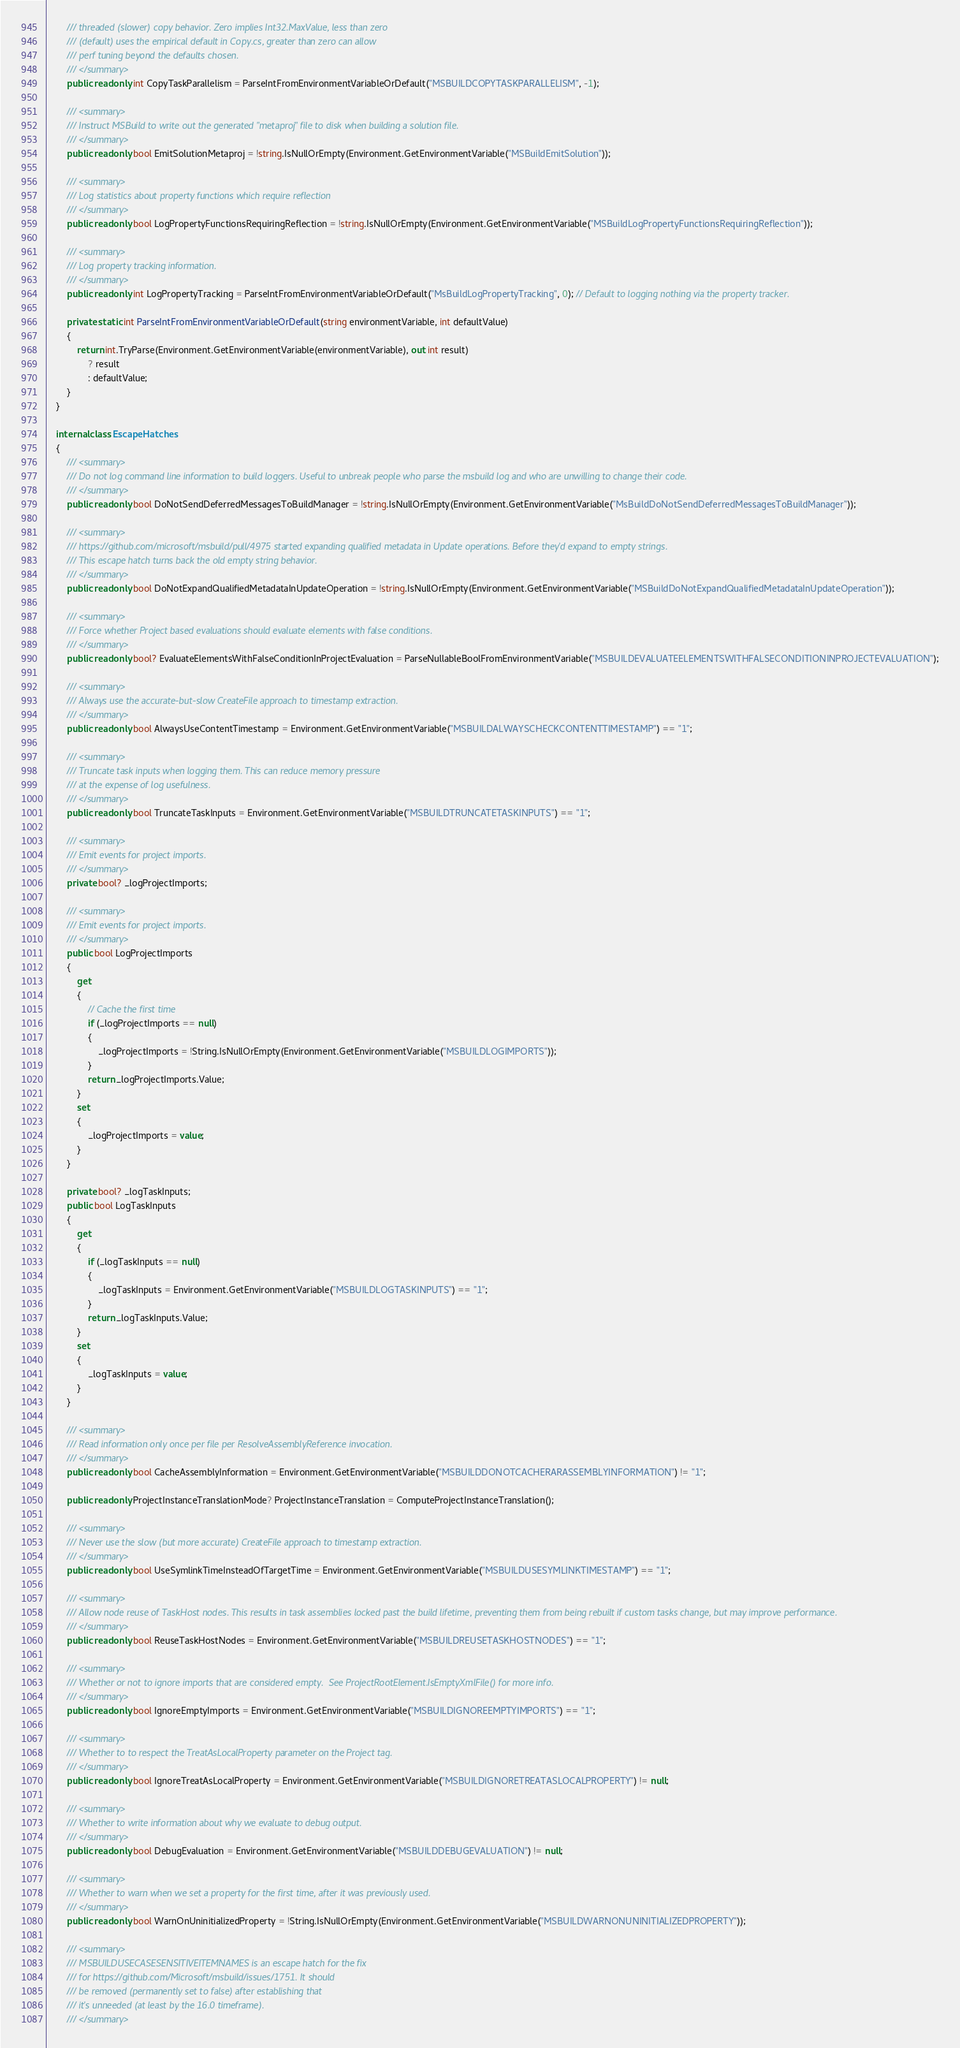Convert code to text. <code><loc_0><loc_0><loc_500><loc_500><_C#_>        /// threaded (slower) copy behavior. Zero implies Int32.MaxValue, less than zero
        /// (default) uses the empirical default in Copy.cs, greater than zero can allow
        /// perf tuning beyond the defaults chosen.
        /// </summary>
        public readonly int CopyTaskParallelism = ParseIntFromEnvironmentVariableOrDefault("MSBUILDCOPYTASKPARALLELISM", -1);

        /// <summary>
        /// Instruct MSBuild to write out the generated "metaproj" file to disk when building a solution file.
        /// </summary>
        public readonly bool EmitSolutionMetaproj = !string.IsNullOrEmpty(Environment.GetEnvironmentVariable("MSBuildEmitSolution"));

        /// <summary>
        /// Log statistics about property functions which require reflection
        /// </summary>
        public readonly bool LogPropertyFunctionsRequiringReflection = !string.IsNullOrEmpty(Environment.GetEnvironmentVariable("MSBuildLogPropertyFunctionsRequiringReflection"));

        /// <summary>
        /// Log property tracking information.
        /// </summary>
        public readonly int LogPropertyTracking = ParseIntFromEnvironmentVariableOrDefault("MsBuildLogPropertyTracking", 0); // Default to logging nothing via the property tracker.

        private static int ParseIntFromEnvironmentVariableOrDefault(string environmentVariable, int defaultValue)
        {
            return int.TryParse(Environment.GetEnvironmentVariable(environmentVariable), out int result)
                ? result
                : defaultValue;
        }
    }

    internal class EscapeHatches
    {
        /// <summary>
        /// Do not log command line information to build loggers. Useful to unbreak people who parse the msbuild log and who are unwilling to change their code.
        /// </summary>
        public readonly bool DoNotSendDeferredMessagesToBuildManager = !string.IsNullOrEmpty(Environment.GetEnvironmentVariable("MsBuildDoNotSendDeferredMessagesToBuildManager"));

        /// <summary>
        /// https://github.com/microsoft/msbuild/pull/4975 started expanding qualified metadata in Update operations. Before they'd expand to empty strings.
        /// This escape hatch turns back the old empty string behavior.
        /// </summary>
        public readonly bool DoNotExpandQualifiedMetadataInUpdateOperation = !string.IsNullOrEmpty(Environment.GetEnvironmentVariable("MSBuildDoNotExpandQualifiedMetadataInUpdateOperation"));

        /// <summary>
        /// Force whether Project based evaluations should evaluate elements with false conditions.
        /// </summary>
        public readonly bool? EvaluateElementsWithFalseConditionInProjectEvaluation = ParseNullableBoolFromEnvironmentVariable("MSBUILDEVALUATEELEMENTSWITHFALSECONDITIONINPROJECTEVALUATION");

        /// <summary>
        /// Always use the accurate-but-slow CreateFile approach to timestamp extraction.
        /// </summary>
        public readonly bool AlwaysUseContentTimestamp = Environment.GetEnvironmentVariable("MSBUILDALWAYSCHECKCONTENTTIMESTAMP") == "1";

        /// <summary>
        /// Truncate task inputs when logging them. This can reduce memory pressure
        /// at the expense of log usefulness.
        /// </summary>
        public readonly bool TruncateTaskInputs = Environment.GetEnvironmentVariable("MSBUILDTRUNCATETASKINPUTS") == "1";

        /// <summary>
        /// Emit events for project imports.
        /// </summary>
        private bool? _logProjectImports;

        /// <summary>
        /// Emit events for project imports.
        /// </summary>
        public bool LogProjectImports
        {
            get
            {
                // Cache the first time
                if (_logProjectImports == null)
                {
                    _logProjectImports = !String.IsNullOrEmpty(Environment.GetEnvironmentVariable("MSBUILDLOGIMPORTS"));
                }
                return _logProjectImports.Value;
            }
            set
            {
                _logProjectImports = value;
            }
        }

        private bool? _logTaskInputs;
        public bool LogTaskInputs
        {
            get
            {
                if (_logTaskInputs == null)
                {
                    _logTaskInputs = Environment.GetEnvironmentVariable("MSBUILDLOGTASKINPUTS") == "1";
                }
                return _logTaskInputs.Value;
            }
            set
            {
                _logTaskInputs = value;
            }
        }

        /// <summary>
        /// Read information only once per file per ResolveAssemblyReference invocation.
        /// </summary>
        public readonly bool CacheAssemblyInformation = Environment.GetEnvironmentVariable("MSBUILDDONOTCACHERARASSEMBLYINFORMATION") != "1";

        public readonly ProjectInstanceTranslationMode? ProjectInstanceTranslation = ComputeProjectInstanceTranslation();

        /// <summary>
        /// Never use the slow (but more accurate) CreateFile approach to timestamp extraction.
        /// </summary>
        public readonly bool UseSymlinkTimeInsteadOfTargetTime = Environment.GetEnvironmentVariable("MSBUILDUSESYMLINKTIMESTAMP") == "1";

        /// <summary>
        /// Allow node reuse of TaskHost nodes. This results in task assemblies locked past the build lifetime, preventing them from being rebuilt if custom tasks change, but may improve performance.
        /// </summary>
        public readonly bool ReuseTaskHostNodes = Environment.GetEnvironmentVariable("MSBUILDREUSETASKHOSTNODES") == "1";

        /// <summary>
        /// Whether or not to ignore imports that are considered empty.  See ProjectRootElement.IsEmptyXmlFile() for more info.
        /// </summary>
        public readonly bool IgnoreEmptyImports = Environment.GetEnvironmentVariable("MSBUILDIGNOREEMPTYIMPORTS") == "1";

        /// <summary>
        /// Whether to to respect the TreatAsLocalProperty parameter on the Project tag. 
        /// </summary>
        public readonly bool IgnoreTreatAsLocalProperty = Environment.GetEnvironmentVariable("MSBUILDIGNORETREATASLOCALPROPERTY") != null;

        /// <summary>
        /// Whether to write information about why we evaluate to debug output.
        /// </summary>
        public readonly bool DebugEvaluation = Environment.GetEnvironmentVariable("MSBUILDDEBUGEVALUATION") != null;

        /// <summary>
        /// Whether to warn when we set a property for the first time, after it was previously used.
        /// </summary>
        public readonly bool WarnOnUninitializedProperty = !String.IsNullOrEmpty(Environment.GetEnvironmentVariable("MSBUILDWARNONUNINITIALIZEDPROPERTY"));

        /// <summary>
        /// MSBUILDUSECASESENSITIVEITEMNAMES is an escape hatch for the fix
        /// for https://github.com/Microsoft/msbuild/issues/1751. It should
        /// be removed (permanently set to false) after establishing that
        /// it's unneeded (at least by the 16.0 timeframe).
        /// </summary></code> 